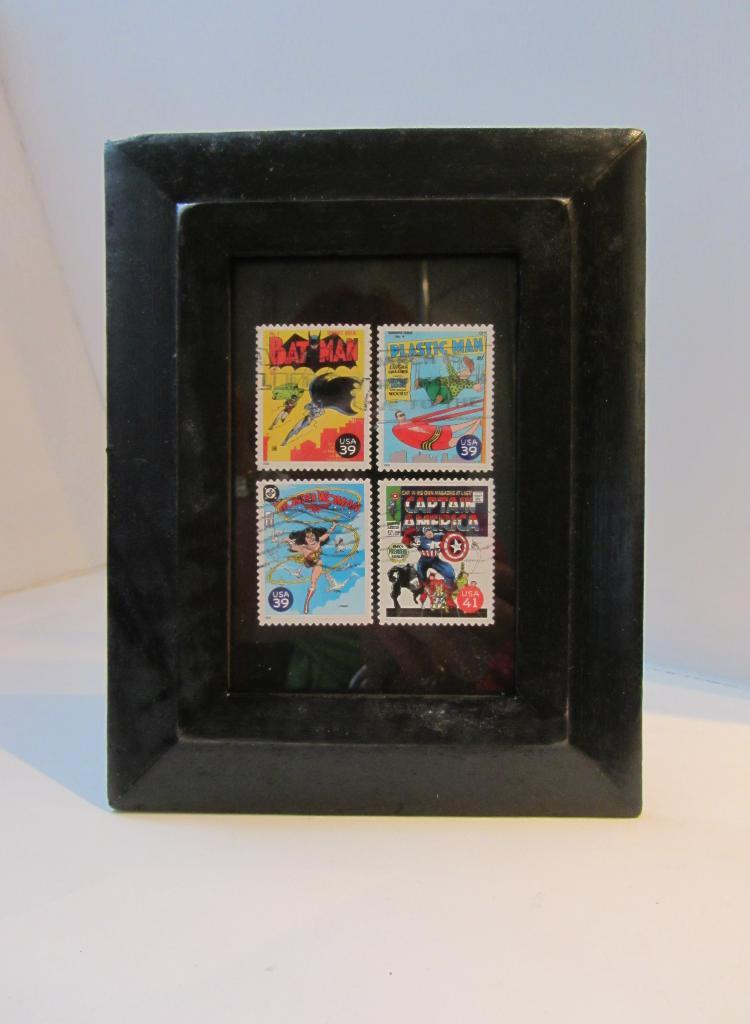Provide a one-sentence caption for the provided image. A black frame holding stamps for 39 cent comic book themed stamps. 